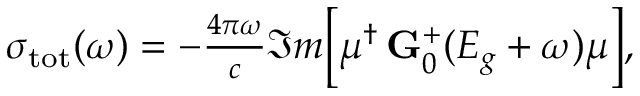<formula> <loc_0><loc_0><loc_500><loc_500>\begin{array} { r } { \sigma _ { t o t } ( \omega ) = - \frac { 4 \pi \omega } { c } \Im m \left [ \mu ^ { \dagger } \, G _ { 0 } ^ { + } ( E _ { g } + \omega ) \mu \right ] , } \end{array}</formula> 